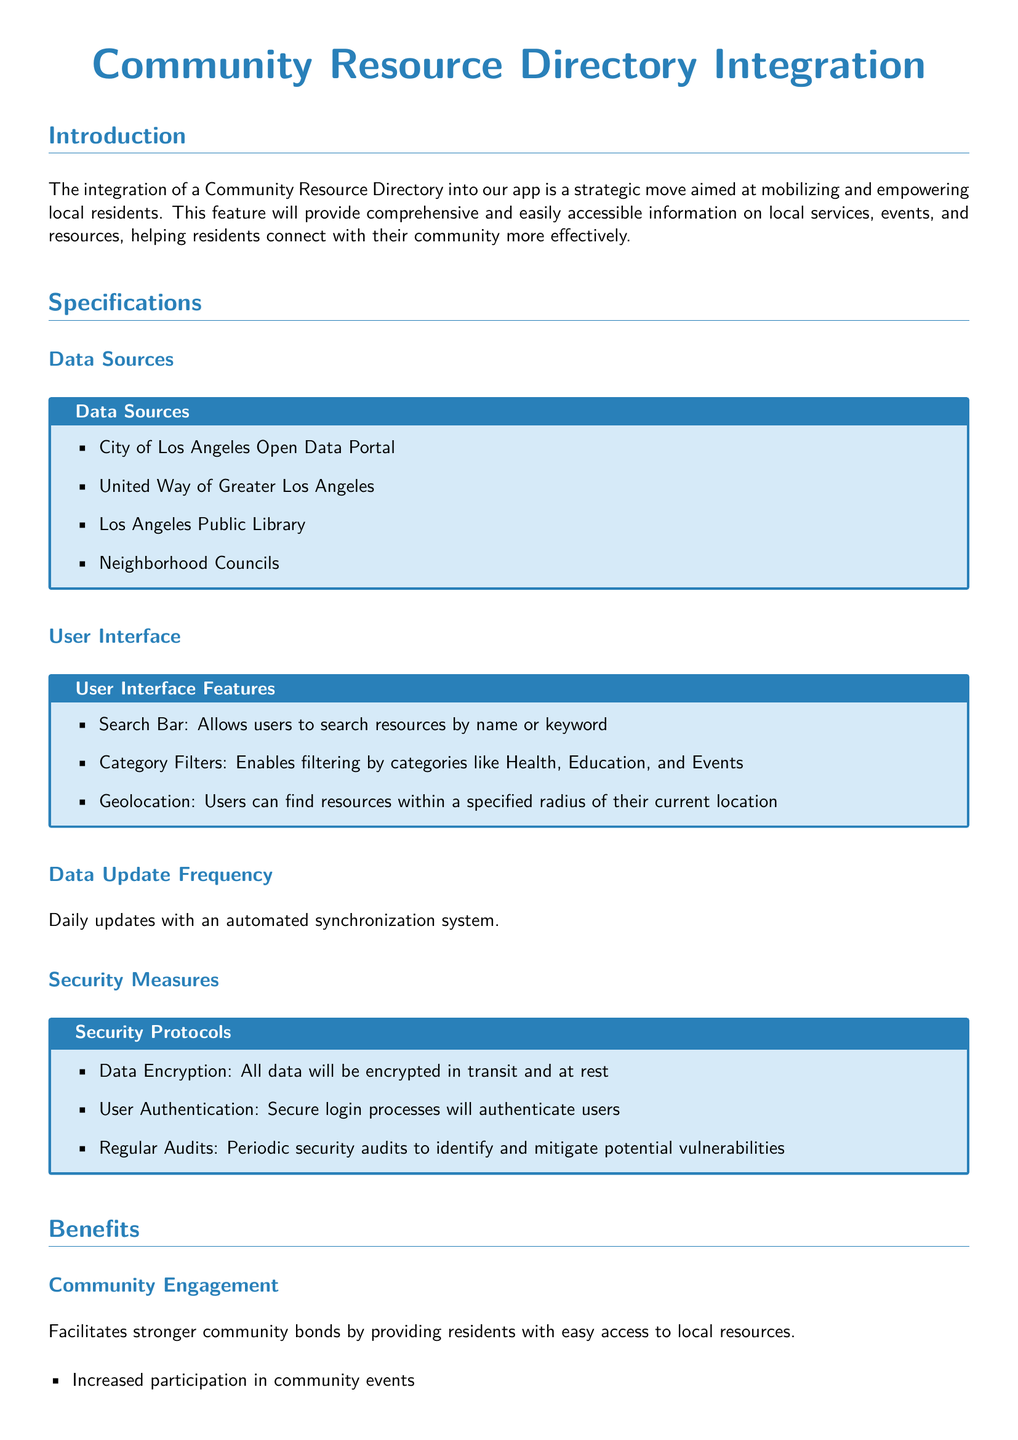What data sources are used for the directory? The document lists specific sources such as the City of Los Angeles Open Data Portal and others.
Answer: City of Los Angeles Open Data Portal, United Way of Greater Los Angeles, Los Angeles Public Library, Neighborhood Councils How often is the data updated? The update frequency for the data integration is specifically mentioned in the document.
Answer: Daily updates What feature allows users to filter resources? The document mentions a specific feature designed for filtering resources into categories.
Answer: Category Filters What is one benefit of the community resource directory? The document highlights various benefits; one is specifically mentioned in the section on community engagement.
Answer: Increased participation in community events What security measure ensures user authentication? The document outlines specific security protocols related to user login.
Answer: Secure login processes 